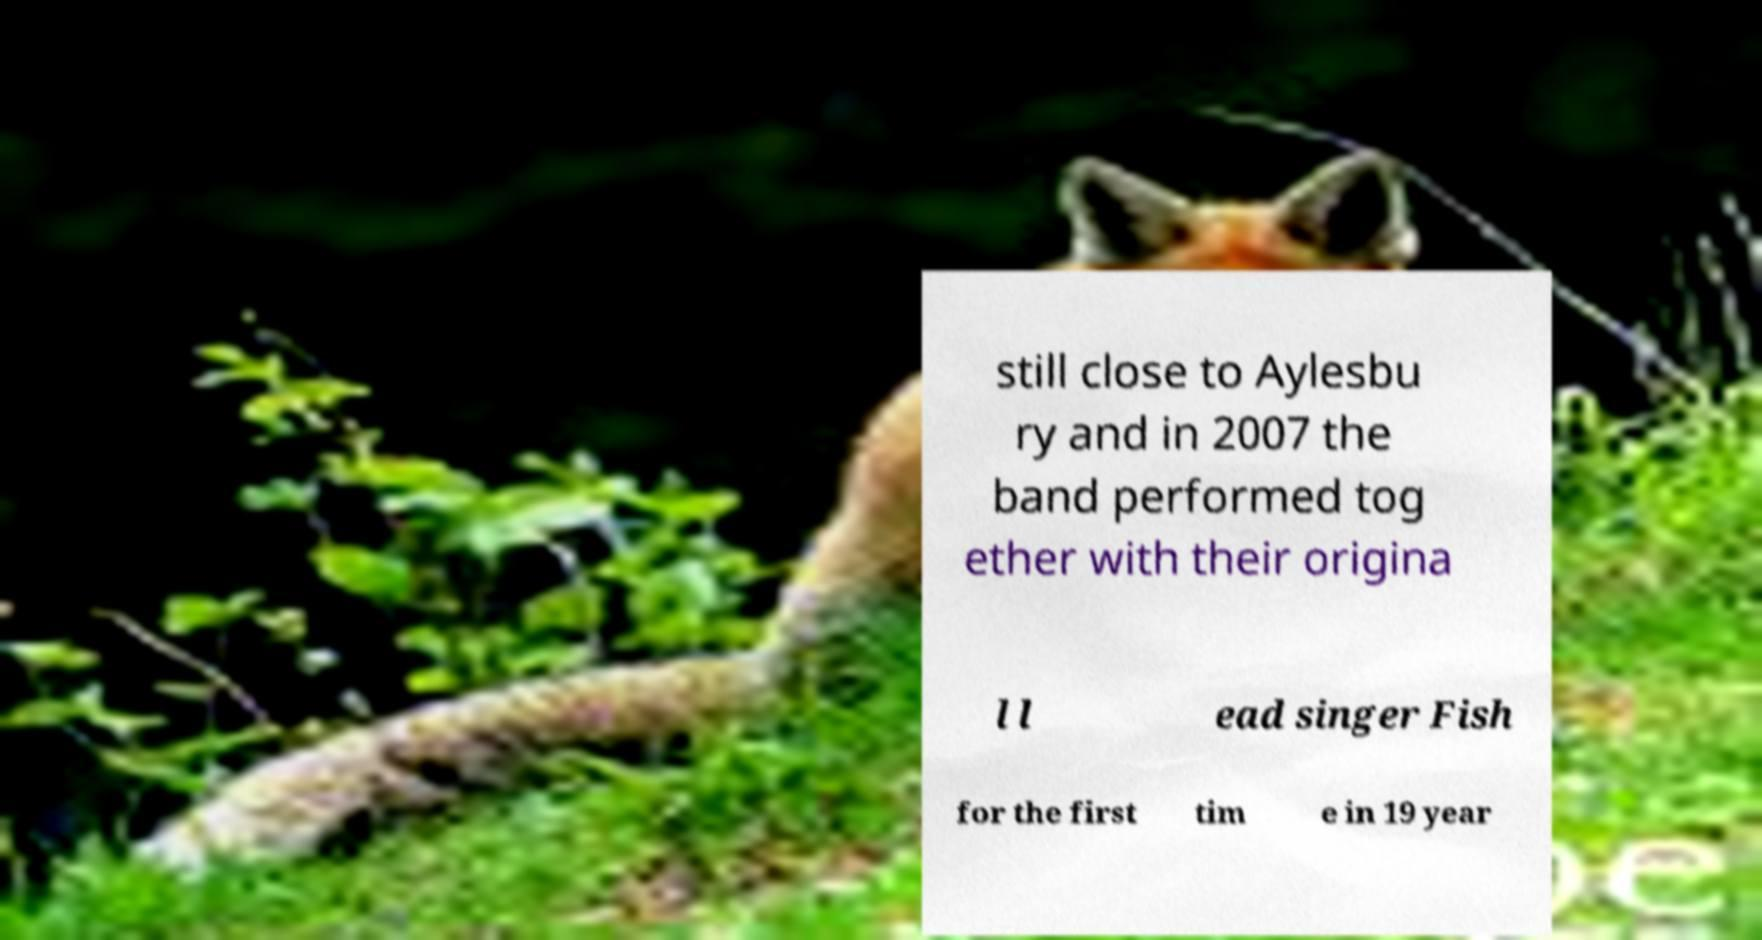Please identify and transcribe the text found in this image. still close to Aylesbu ry and in 2007 the band performed tog ether with their origina l l ead singer Fish for the first tim e in 19 year 